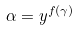<formula> <loc_0><loc_0><loc_500><loc_500>\alpha = y ^ { f ( \gamma ) }</formula> 